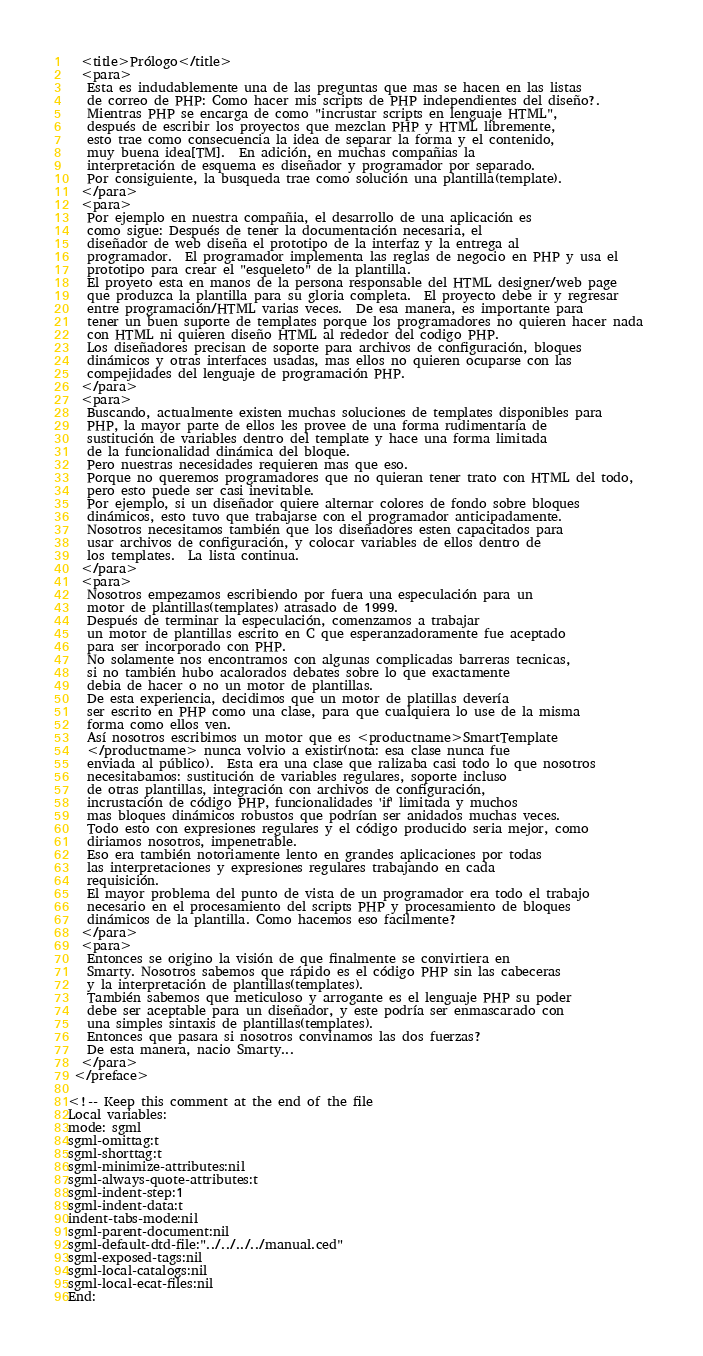<code> <loc_0><loc_0><loc_500><loc_500><_XML_>  <title>Prólogo</title>
  <para>
   Esta es indudablemente una de las preguntas que mas se hacen en las listas 
   de correo de PHP: Como hacer mis scripts de PHP independientes del diseño?.
   Mientras PHP se encarga de como "incrustar scripts en lenguaje HTML",
   después de escribir los proyectos que mezclan PHP y HTML libremente, 
   esto trae como consecuencia la idea de separar la forma y el contenido, 
   muy buena idea[TM].  En adición, en muchas compañias la 
   interpretación de esquema es diseñador y programador por separado. 
   Por consiguiente, la busqueda trae como solución una plantilla(template).
  </para>
  <para>
   Por ejemplo en nuestra compañia, el desarrollo de una aplicación es
   como sigue: Después de tener la documentación necesaria, el 
   diseñador de web diseña el prototipo de la interfaz y la entrega al 
   programador.  El programador implementa las reglas de negocio en PHP y usa el
   prototipo para crear el "esqueleto" de la plantilla.  
   El proyeto esta en manos de la persona responsable del HTML designer/web page 
   que produzca la plantilla para su gloria completa.  El proyecto debe ir y regresar 
   entre programación/HTML varias veces.  De esa manera, es importante para 
   tener un buen suporte de templates porque los programadores no quieren hacer nada 
   con HTML ni quieren diseño HTML al rededor del codigo PHP.
   Los diseñadores precisan de soporte para archivos de configuración, bloques
   dinámicos y otras interfaces usadas, mas ellos no quieren ocuparse con las
   compejidades del lenguaje de programación PHP.
  </para>
  <para>
   Buscando, actualmente existen muchas soluciones de templates disponibles para
   PHP, la mayor parte de ellos les provee de una forma rudimentaria de 
   sustitución de variables dentro del template y hace una forma limitada 
   de la funcionalidad dinámica del bloque.  
   Pero nuestras necesidades requieren mas que eso.  
   Porque no queremos programadores que no quieran tener trato con HTML del todo, 
   pero esto puede ser casi inevitable.
   Por ejemplo, si un diseñador quiere alternar colores de fondo sobre bloques 
   dinámicos, esto tuvo que trabajarse con el programador anticipadamente.
   Nosotros necesitamos también que los diseñadores esten capacitados para 
   usar archivos de configuración, y colocar variables de ellos dentro de 
   los templates.  La lista continua.
  </para>
  <para>
   Nosotros empezamos escribiendo por fuera una especulación para un
   motor de plantillas(templates) atrasado de 1999.
   Después de terminar la especulación, comenzamos a trabajar 
   un motor de plantillas escrito en C que esperanzadoramente fue aceptado 
   para ser incorporado con PHP.
   No solamente nos encontramos con algunas complicadas barreras tecnicas, 
   si no también hubo acalorados debates sobre lo que exactamente 
   debia de hacer o no un motor de plantillas.
   De esta experiencia, decidimos que un motor de platillas devería 
   ser escrito en PHP como una clase, para que cualquiera lo use de la misma
   forma como ellos ven.
   Así nosotros escribimos un motor que es <productname>SmartTemplate
   </productname> nunca volvio a existir(nota: esa clase nunca fue
   enviada al público).  Esta era una clase que ralizaba casi todo lo que nosotros 
   necesitabamos: sustitución de variables regulares, soporte incluso 
   de otras plantillas, integración con archivos de configuración, 
   incrustación de código PHP, funcionalidades 'if' limitada y muchos
   mas bloques dinámicos robustos que podrían ser anidados muchas veces.
   Todo esto con expresiones regulares y el código producido seria mejor, como 
   diriamos nosotros, impenetrable.  
   Eso era también notoriamente lento en grandes aplicaciones por todas 
   las interpretaciones y expresiones regulares trabajando en cada 
   requisición.
   El mayor problema del punto de vista de un programador era todo el trabajo
   necesario en el procesamiento del scripts PHP y procesamiento de bloques
   dinámicos de la plantilla. Como hacemos eso facilmente?
  </para>
  <para>
   Entonces se origino la visión de que finalmente se convirtiera en
   Smarty. Nosotros sabemos que rápido es el código PHP sin las cabeceras 
   y la interpretación de plantillas(templates).
   También sabemos que meticuloso y arrogante es el lenguaje PHP su poder 
   debe ser aceptable para un diseñador, y este podría ser enmascarado con 
   una simples sintaxis de plantillas(templates).
   Entonces que pasara si nosotros convinamos las dos fuerzas?
   De esta manera, nacio Smarty...
  </para>
 </preface>

<!-- Keep this comment at the end of the file
Local variables:
mode: sgml
sgml-omittag:t
sgml-shorttag:t
sgml-minimize-attributes:nil
sgml-always-quote-attributes:t
sgml-indent-step:1
sgml-indent-data:t
indent-tabs-mode:nil
sgml-parent-document:nil
sgml-default-dtd-file:"../../../../manual.ced"
sgml-exposed-tags:nil
sgml-local-catalogs:nil
sgml-local-ecat-files:nil
End:</code> 